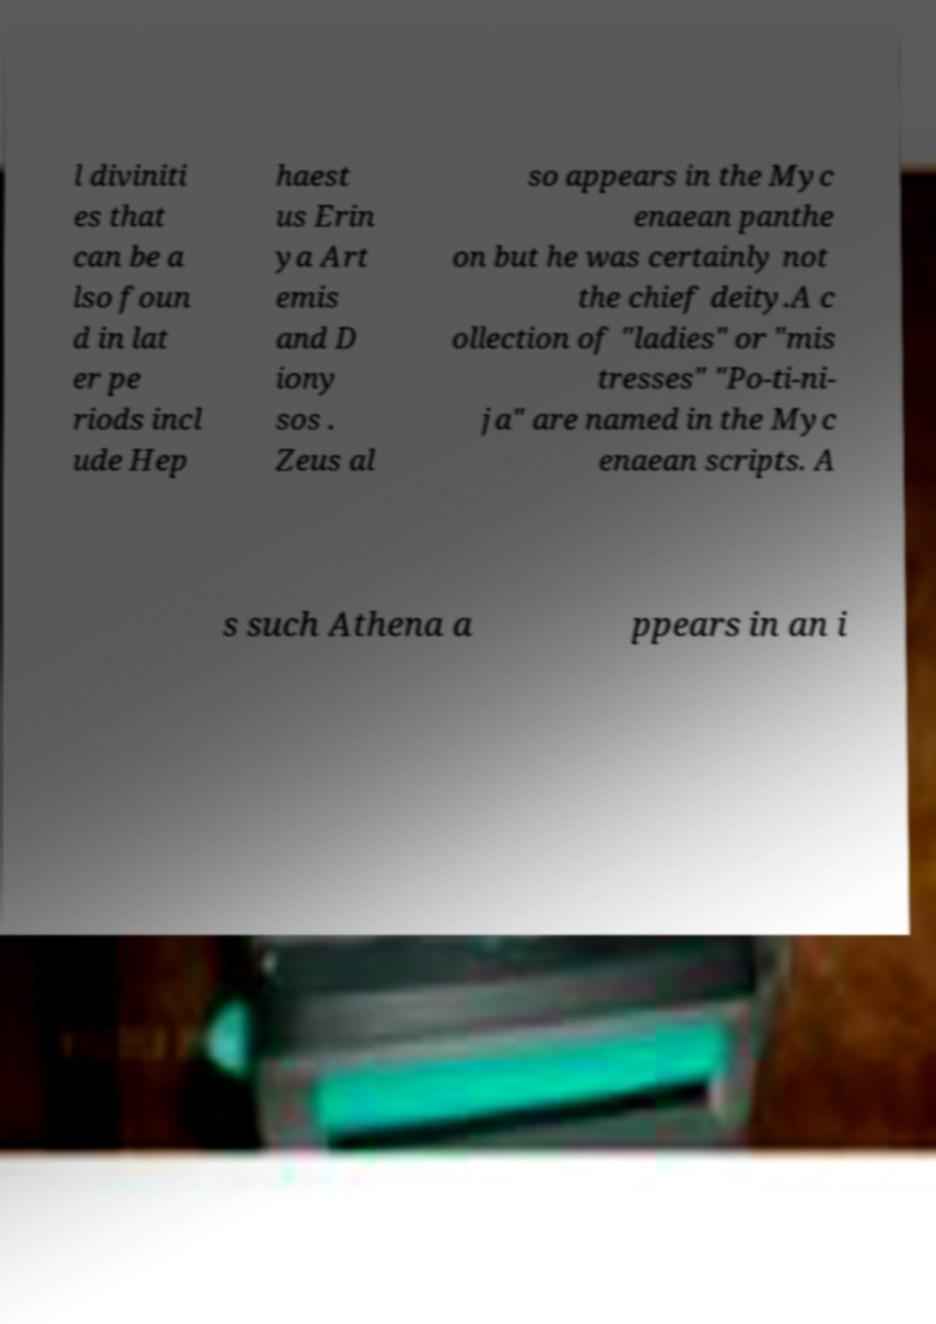Can you accurately transcribe the text from the provided image for me? l diviniti es that can be a lso foun d in lat er pe riods incl ude Hep haest us Erin ya Art emis and D iony sos . Zeus al so appears in the Myc enaean panthe on but he was certainly not the chief deity.A c ollection of "ladies" or "mis tresses" "Po-ti-ni- ja" are named in the Myc enaean scripts. A s such Athena a ppears in an i 